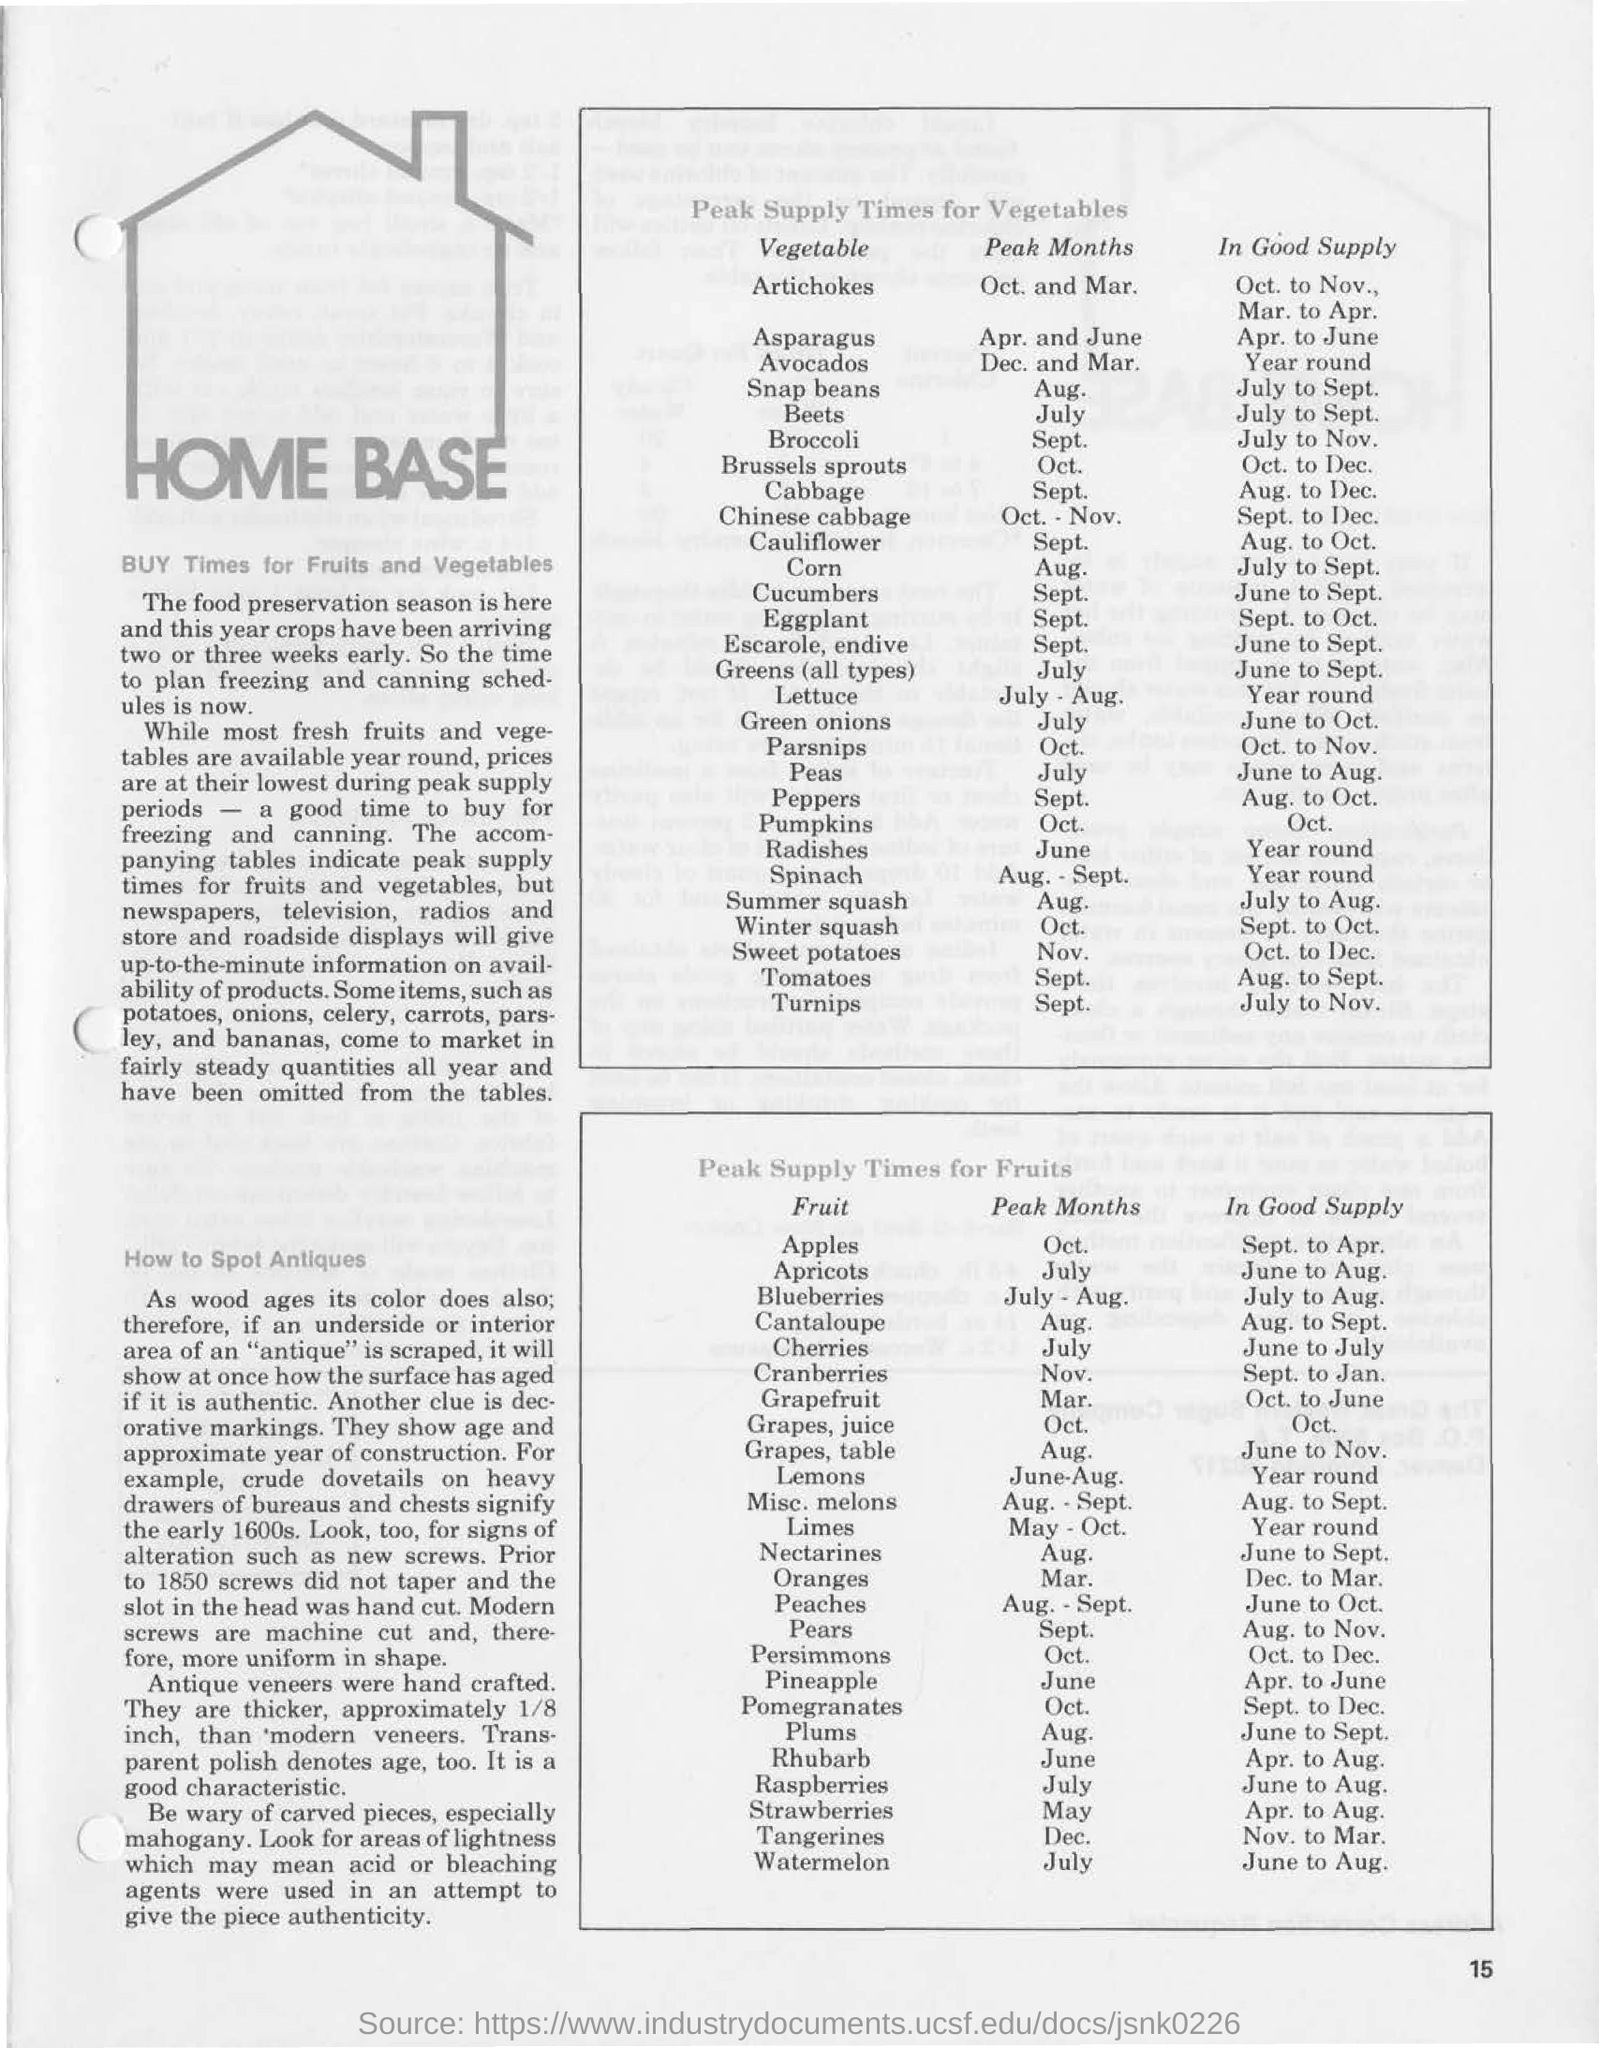Point out several critical features in this image. The peak supply time for apples is in October. The peak supply time for artichokes is in October and March. From August to December, cabbage is in good supply. The peak supply time for beets is in July. Plums are available in abundance from June to September. 